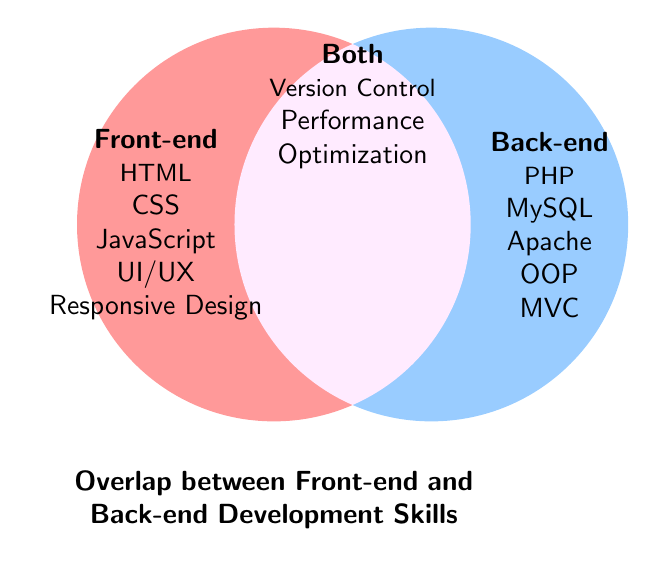What skills are unique to front-end development? Skills under the "Front-end" section are unique to front-end development. These include HTML, CSS, JavaScript, UI/UX, and Responsive Design.
Answer: HTML, CSS, JavaScript, UI/UX, Responsive Design What skills are mentioned in the overlap area of the Venn diagram? The skills listed in the "Both" section overlap between front-end and back-end development. These include Version Control, Performance, and Optimization.
Answer: Version Control, Performance, Optimization How many skills are unique to back-end development? There are five skills listed under the "Back-end" section. These are PHP, MySQL, Apache, OOP, and MVC.
Answer: 5 Which section lists skills related to user interface and experience? The skill UI/UX related to user interface and experience is listed under the "Front-end" section.
Answer: Front-end Is JavaScript listed in the overlap area between front-end and back-end skills? JavaScript is specifically listed under the "Front-end" section, not in the overlap area.
Answer: No Between front-end and back-end development, which has more unique skills mentioned? The front-end section lists six unique skills while the back-end lists five. Therefore, front-end has more unique skills.
Answer: Front-end What skills are common between front-end and back-end development? Skills listed in the "Both" section denote common skills between front-end and back-end development, which include Version Control, Performance, and Optimization.
Answer: Version Control, Performance, Optimization Which section encompasses knowledge of the MVC architecture model? The MVC architecture model is listed under the "Back-end" section.
Answer: Back-end Identify one front-end and one back-end skill related to server technologies. Apache is related to server technologies in the "Back-end" section, while there is no specific front-end skill related to server technologies explicitly listed.
Answer: Apache Which section is associated with the concept of responsiveness in web design? The concept of Responsive Design is listed under the "Front-end" section.
Answer: Front-end 